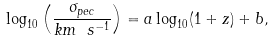Convert formula to latex. <formula><loc_0><loc_0><loc_500><loc_500>\log _ { 1 0 } \left ( \frac { \sigma _ { p e c } } { k m \ s ^ { - 1 } } \right ) = a \log _ { 1 0 } ( 1 + z ) + b ,</formula> 